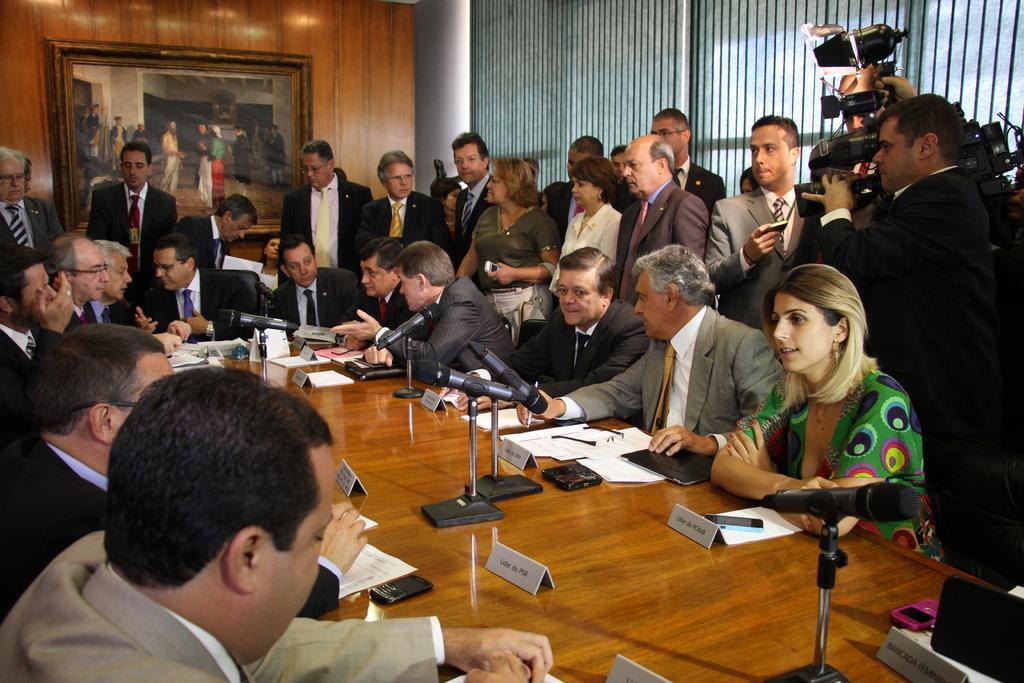How would you summarize this image in a sentence or two? In this picture we can see a few microphones, name boards, phones, a laptop and other objects visible on a wooden table. We can see a few people sitting on the chair. We can see some people standing at the back. A person is holding a camera on the right side. There are a few frames on a wooden surface. We can see a pillar and a window shades on the right side. 